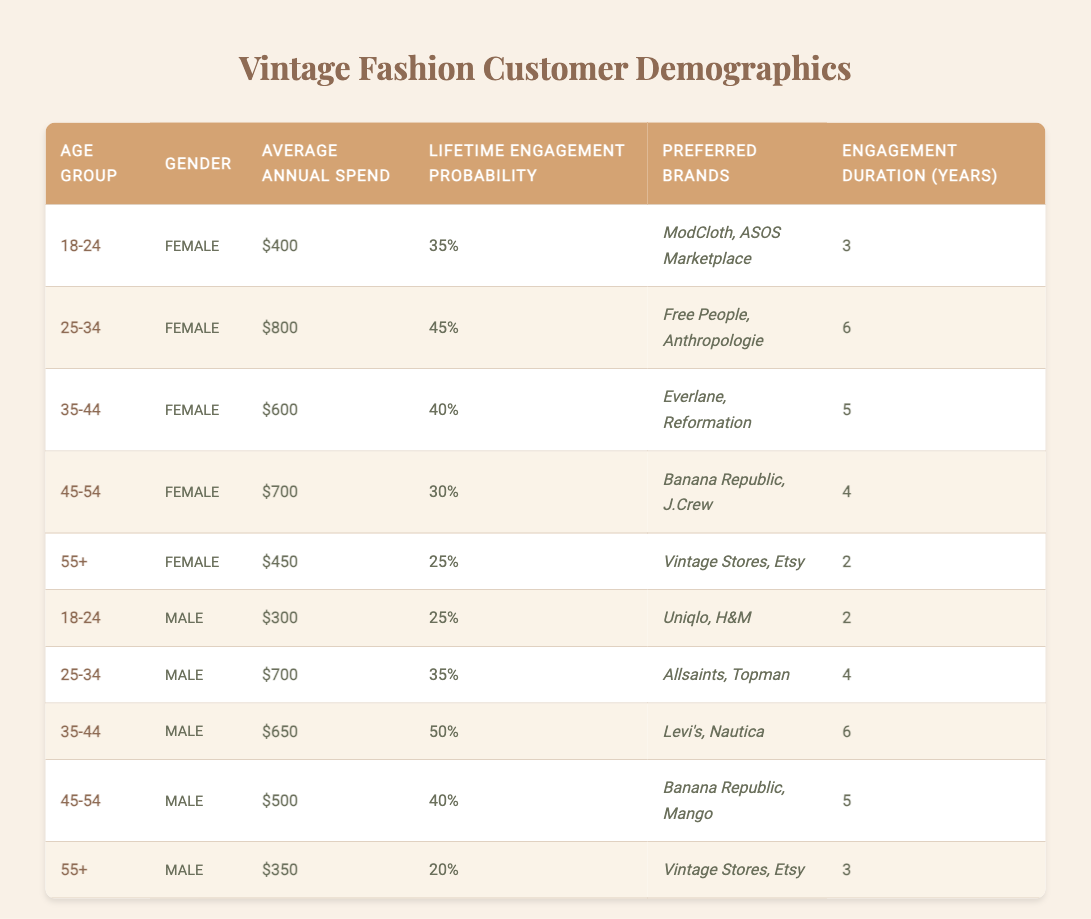What is the average annual spend for female customers aged 25-34? According to the table, the average annual spend for female customers aged 25-34 is $800.
Answer: $800 What is the lifetimes engagement probability for male customers aged 55 and older? Based on the table, male customers aged 55 and older have a lifetime engagement probability of 20%.
Answer: 20% Which age group has the highest average annual spend among female customers? The age group 25-34 has the highest average annual spend for female customers at $800.
Answer: 25-34 If we compare female customers aged 18-24 and 45-54, who has a higher engagement duration? Female customers aged 18-24 have an engagement duration of 3 years, while those aged 45-54 have 4 years. 4 years is greater, so 45-54 has higher engagement duration.
Answer: 45-54 What is the total average annual spend for male customers across all age groups? The average annual spends for male customers are $300, $700, $650, $500, and $350. Summing these values gives $300 + $700 + $650 + $500 + $350 = $2500. Then, we take the average: $2500 / 5 = $500.
Answer: $500 Is it true that the preferred brands for male customers aged 35-44 include Levi's and Nautica? Yes, the table indicates that male customers aged 35-44 prefer brands such as Levi's and Nautica.
Answer: Yes How much more does the average annual spend of female customers aged 25-34 compare to male customers aged 25-34? For female customers aged 25-34, the average annual spend is $800, while for male customers in the same age group, it is $700. The difference is $800 - $700 = $100, meaning female customers spend $100 more.
Answer: $100 What is the engagement duration for female customers aged 55 and older? The engagement duration for female customers aged 55 and older is 2 years according to the table.
Answer: 2 years Which gender among the age group 35-44 has a higher lifetime engagement probability? The lifetime engagement probability for male customers aged 35-44 is 50%, which is higher than the 40% for female customers aged 35-44.
Answer: Male What is the average engagement duration for all female customers listed in the table? The engagement durations for female customers are 3, 6, 5, 4, and 2 years. Summing these gives 3 + 6 + 5 + 4 + 2 = 20 years. To find the average: 20 / 5 = 4 years.
Answer: 4 years 